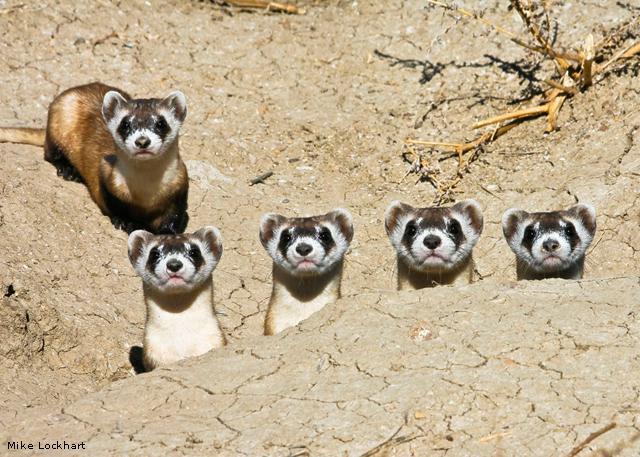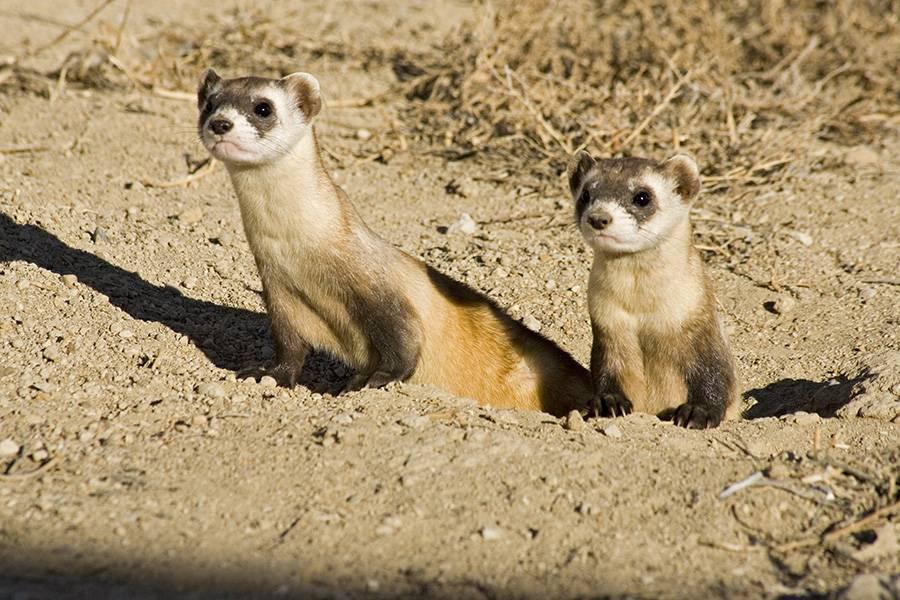The first image is the image on the left, the second image is the image on the right. Considering the images on both sides, is "The right image contains exactly two ferrets." valid? Answer yes or no. Yes. 